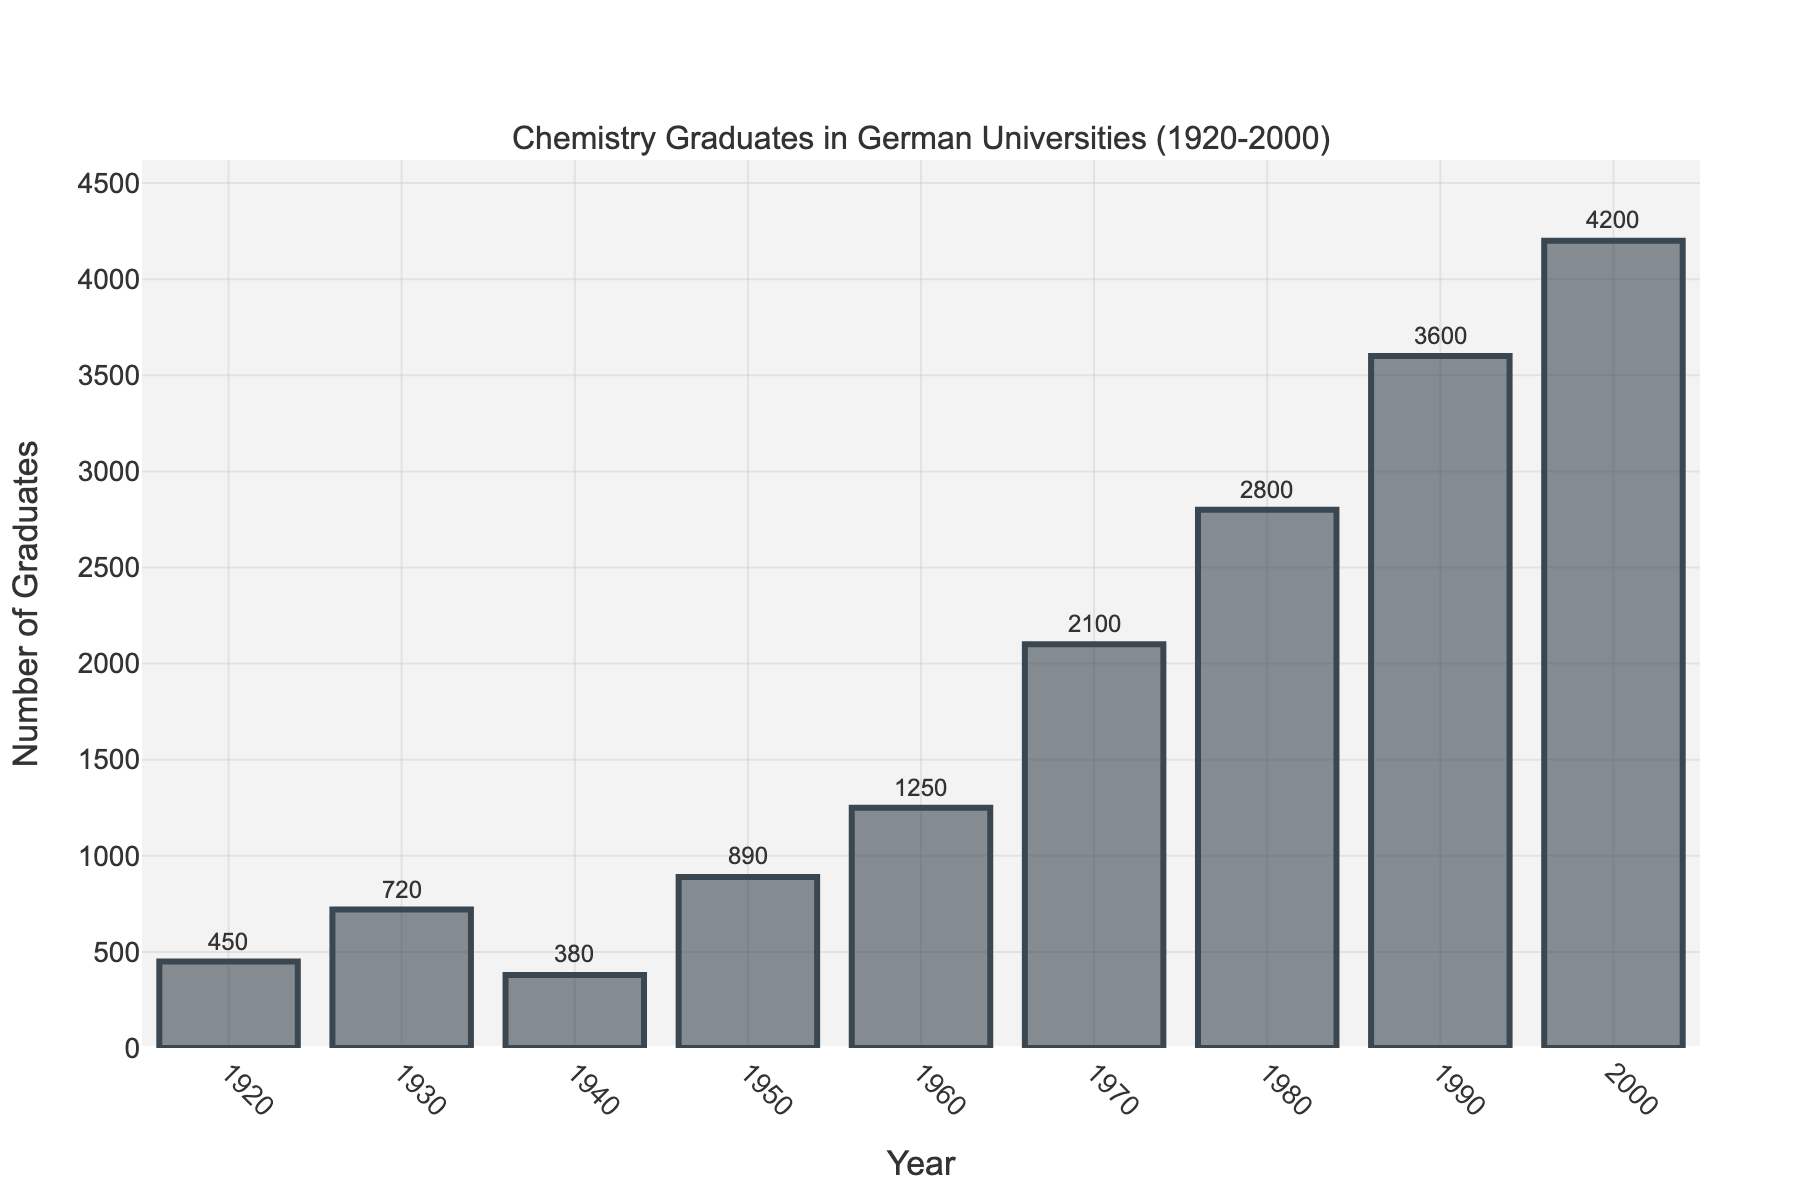How many chemistry graduates were there in 1940? The bar corresponding to the year 1940 reaches up to 380. Thus, the number of graduates is 380.
Answer: 380 Which year had the highest number of chemistry graduates? The tallest bar in the graph corresponds to the year 2000 with the number of graduates reaching 4200.
Answer: 2000 What is the difference in the number of chemistry graduates between 1950 and 1980? The number of graduates in 1950 is 890 and in 1980 it is 2800. The difference is 2800 - 890 = 1910.
Answer: 1910 What is the average number of graduates per decade from 1950 to 2000 (inclusive)? Sum the graduates from 1950 to 2000 (inclusive): 890 + 1250 + 2100 + 2800 + 3600 + 4200 = 14840. There are 6 decades, so the average is 14840 / 6 ≈ 2473.33
Answer: 2473.33 In which decade did the number of graduates increase the most compared to the previous decade? Calculate the increase for each decade: 1950-1960: 1250 - 890 = 360; 1960-1970: 2100 - 1250 = 850; 1970-1980: 2800 - 2100 = 700; 1980-1990: 3600 - 2800 = 800; 1990-2000: 4200 - 3600 = 600. The largest increase is from 1960-1970 with 850 graduates.
Answer: 1960-1970 Which two consecutive decades saw the smallest increase in the number of graduates? Calculate the increase for each pair of consecutive decades: 1950-1960: 360; 1960-1970: 850; 1970-1980: 700; 1980-1990: 800; 1990-2000: 600. The smallest increase is from 1950-1960 with 360 graduates.
Answer: 1950-1960 How many more graduates were there in 1990 compared to 1920? The number of graduates in 1990 is 3600, and in 1920 it is 450. The difference is 3600 - 450 = 3150.
Answer: 3150 Which year saw a decline in the number of graduates compared to its previous decade? By comparing each decade: 1930 (720) to 1940 (380) shows a decline.
Answer: 1940 